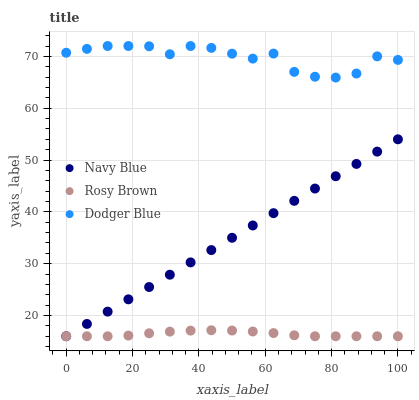Does Rosy Brown have the minimum area under the curve?
Answer yes or no. Yes. Does Dodger Blue have the maximum area under the curve?
Answer yes or no. Yes. Does Dodger Blue have the minimum area under the curve?
Answer yes or no. No. Does Rosy Brown have the maximum area under the curve?
Answer yes or no. No. Is Navy Blue the smoothest?
Answer yes or no. Yes. Is Dodger Blue the roughest?
Answer yes or no. Yes. Is Rosy Brown the smoothest?
Answer yes or no. No. Is Rosy Brown the roughest?
Answer yes or no. No. Does Navy Blue have the lowest value?
Answer yes or no. Yes. Does Dodger Blue have the lowest value?
Answer yes or no. No. Does Dodger Blue have the highest value?
Answer yes or no. Yes. Does Rosy Brown have the highest value?
Answer yes or no. No. Is Navy Blue less than Dodger Blue?
Answer yes or no. Yes. Is Dodger Blue greater than Navy Blue?
Answer yes or no. Yes. Does Navy Blue intersect Rosy Brown?
Answer yes or no. Yes. Is Navy Blue less than Rosy Brown?
Answer yes or no. No. Is Navy Blue greater than Rosy Brown?
Answer yes or no. No. Does Navy Blue intersect Dodger Blue?
Answer yes or no. No. 